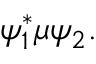<formula> <loc_0><loc_0><loc_500><loc_500>\psi _ { 1 } ^ { * } \mu \psi _ { 2 } .</formula> 